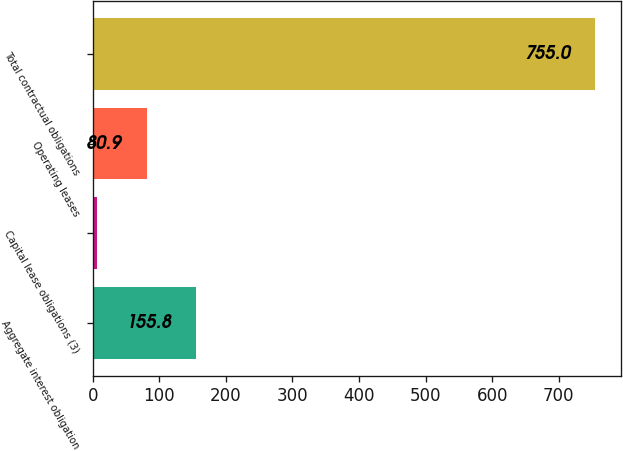Convert chart to OTSL. <chart><loc_0><loc_0><loc_500><loc_500><bar_chart><fcel>Aggregate interest obligation<fcel>Capital lease obligations (3)<fcel>Operating leases<fcel>Total contractual obligations<nl><fcel>155.8<fcel>6<fcel>80.9<fcel>755<nl></chart> 